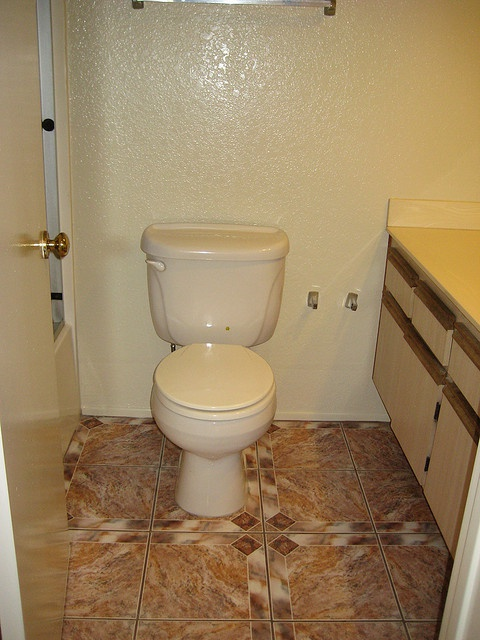Describe the objects in this image and their specific colors. I can see a toilet in gray and tan tones in this image. 